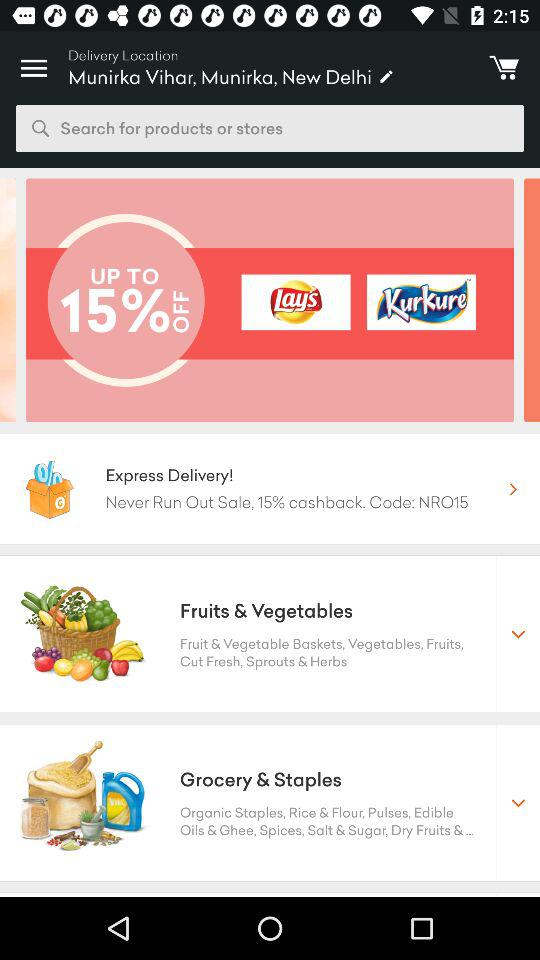How much cashback is given on express delivery? The cashback is 15%. 